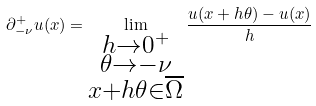<formula> <loc_0><loc_0><loc_500><loc_500>\partial ^ { + } _ { - \nu } u ( x ) = \lim _ { \substack { h \to 0 ^ { + } \\ \theta \to - \nu \\ x + h \theta \in \overline { \Omega } } } \frac { u ( x + h \theta ) - u ( x ) } { h }</formula> 